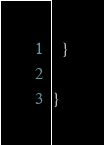<code> <loc_0><loc_0><loc_500><loc_500><_Scala_>  }

}
</code> 